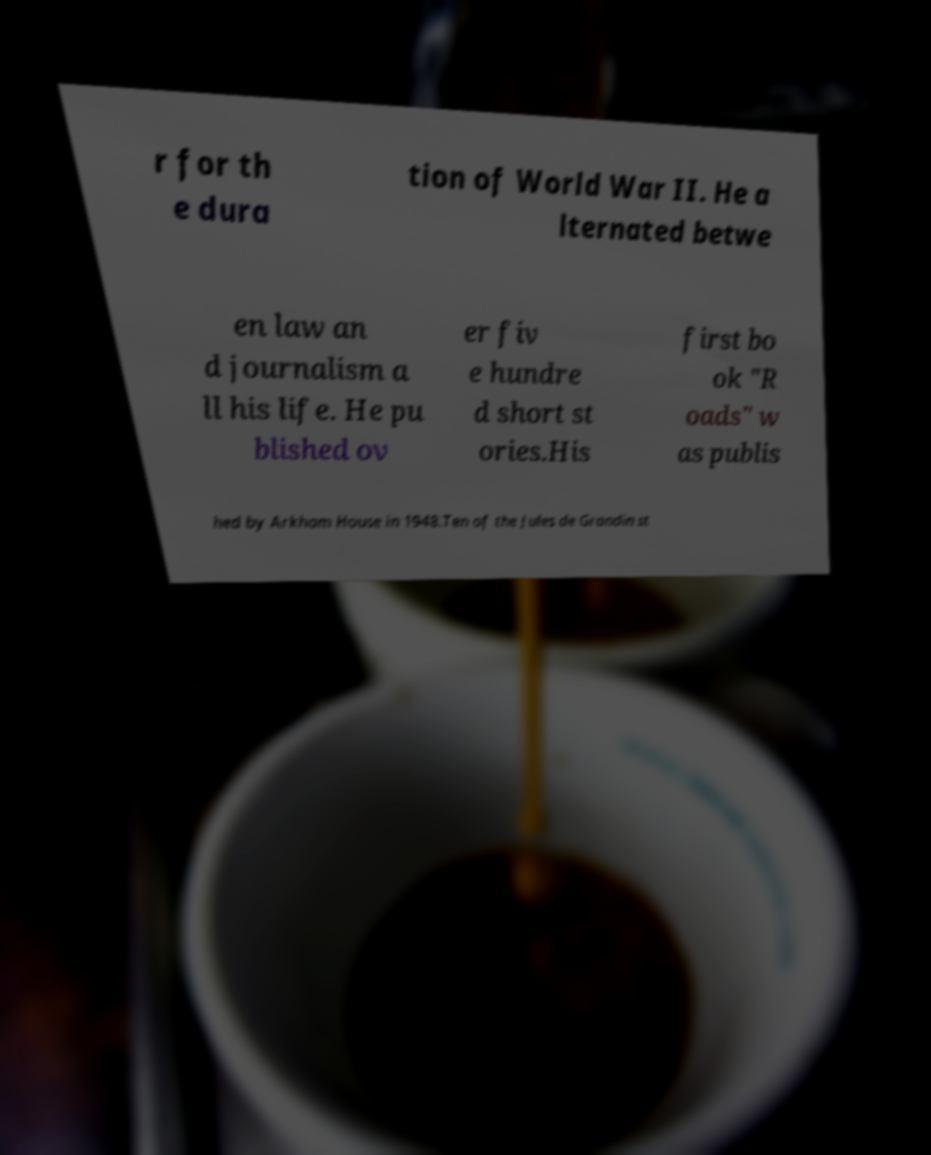What messages or text are displayed in this image? I need them in a readable, typed format. r for th e dura tion of World War II. He a lternated betwe en law an d journalism a ll his life. He pu blished ov er fiv e hundre d short st ories.His first bo ok "R oads" w as publis hed by Arkham House in 1948.Ten of the Jules de Grandin st 